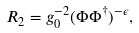<formula> <loc_0><loc_0><loc_500><loc_500>R _ { 2 } = g _ { 0 } ^ { - 2 } ( \Phi { \Phi } ^ { \dagger } ) ^ { - \epsilon } ,</formula> 